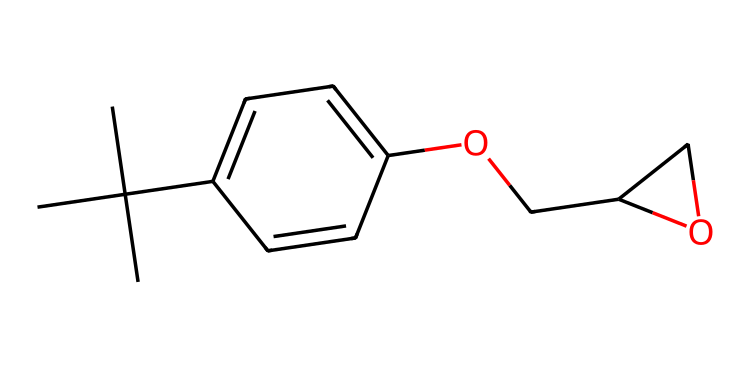what is the total number of carbon atoms in this chemical? To determine the total number of carbon atoms, we can analyze the SMILES representation. The chain begins with "CC(C)(C)", indicating three methyl groups attached to a main carbon, contributing four carbons. The "c1ccc" part indicates a benzene ring with three additional carbons. In total, there are seven carbon atoms from this section. Adding these gives a total of 11 carbon atoms in the full structure.
Answer: eleven how many oxygen atoms are present in this molecule? In the SMILES, we can spot oxygen atoms by looking for "O" characters. There is one "O" in "OCC" and one more in "OCC2CO2", making a total of two oxygen atoms in the entire structure.
Answer: two what is the functional group present in this chemical that contributes to its adhesive properties? The molecule contains an ether link (OCC) as indicated by the presence of an oxygen atom bonded to carbon chains. This structure is commonly associated with adhesive properties in epoxy resins. The ether functional group is primarily responsible for the molecular interactions leading to strong adhesive characteristics.
Answer: ether how many hydrogen atoms are attached to the carbon atoms in this molecule? To find the total number of hydrogen atoms, we first establish the number of hydrogens that each carbon can bond with (which is typically four total bonds per carbon). Considering the attachment of other atoms or groups reduces the number of available hydrogen bonds. Through careful inspection of the structure and applying the valency of carbon, we can ascertain that this structure holds 14 hydrogen atoms.
Answer: fourteen what type of polymer does this molecule represent when used in preservation? This chemical is a type of epoxy resin, which is formed by the polymerization of epoxide monomers. Epoxy resins are widely utilized in conservation due to their strong adhesive properties, chemical resistance, and durability, making them ideal for the restoration and preservation of artifacts.
Answer: epoxy resin 